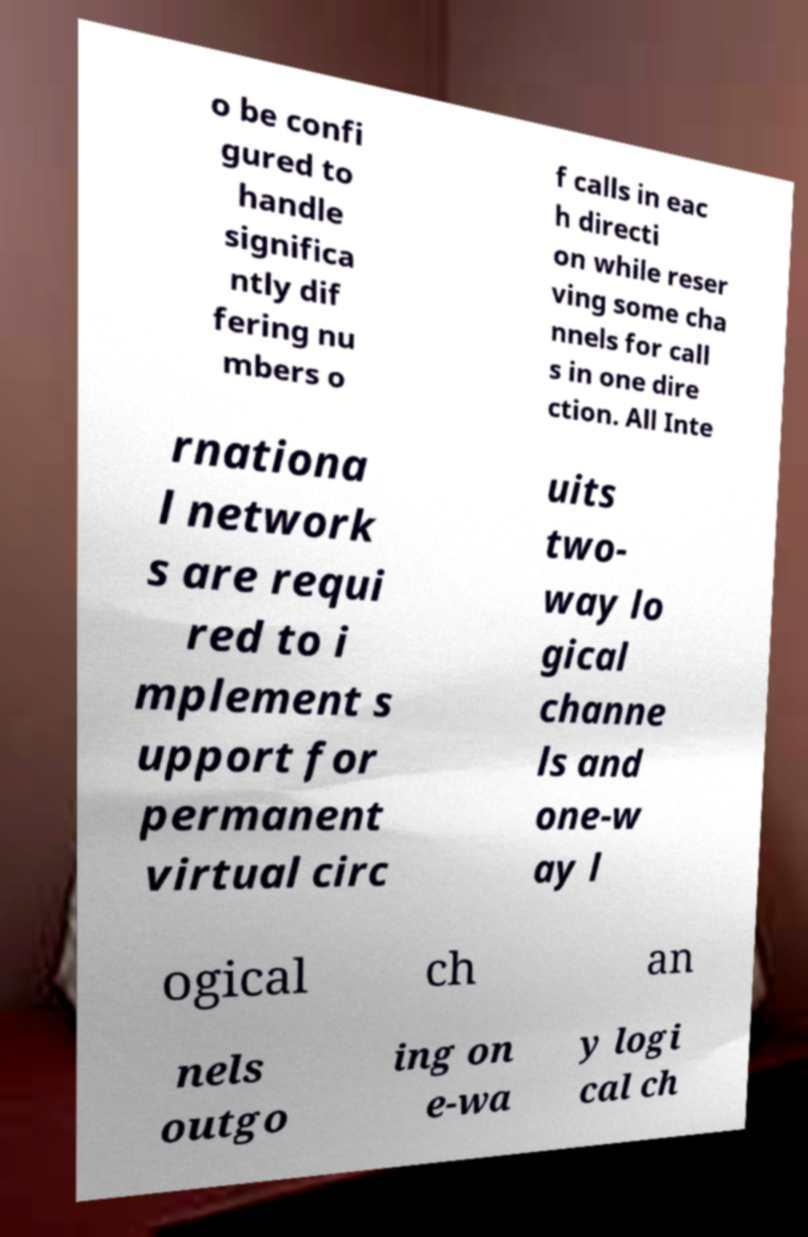There's text embedded in this image that I need extracted. Can you transcribe it verbatim? o be confi gured to handle significa ntly dif fering nu mbers o f calls in eac h directi on while reser ving some cha nnels for call s in one dire ction. All Inte rnationa l network s are requi red to i mplement s upport for permanent virtual circ uits two- way lo gical channe ls and one-w ay l ogical ch an nels outgo ing on e-wa y logi cal ch 